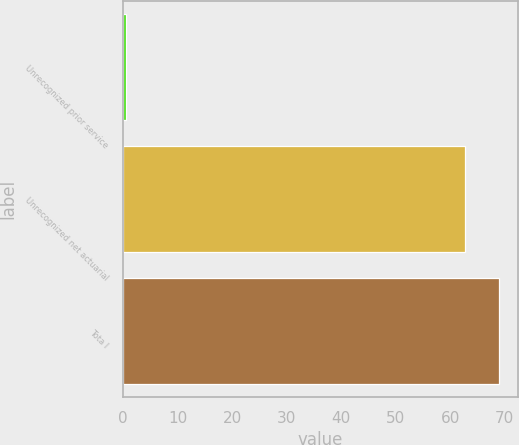<chart> <loc_0><loc_0><loc_500><loc_500><bar_chart><fcel>Unrecognized prior service<fcel>Unrecognized net actuarial<fcel>Tota l<nl><fcel>0.6<fcel>62.7<fcel>68.97<nl></chart> 